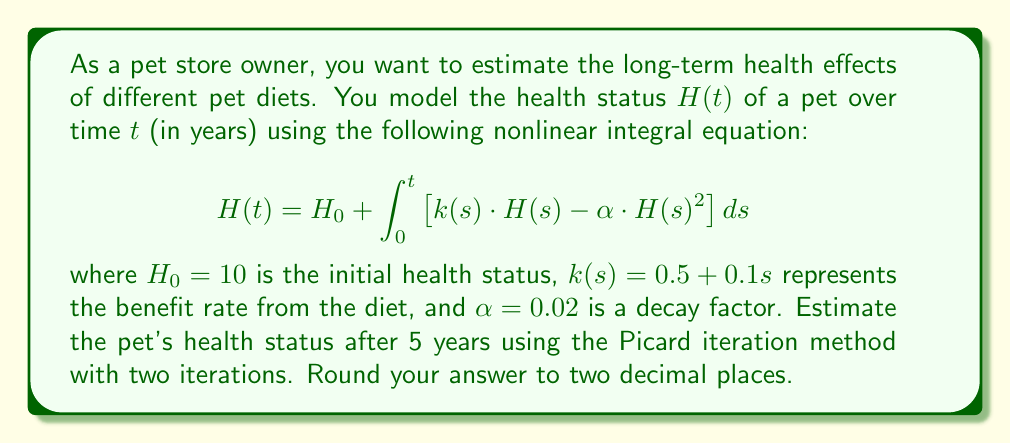Give your solution to this math problem. To solve this problem using the Picard iteration method, we'll follow these steps:

1) Start with the initial approximation $H_0(t) = 10$ (constant function).

2) For the first iteration, substitute $H_0(t)$ into the right-hand side of the equation:

   $$H_1(t) = 10 + \int_0^t \left[(0.5 + 0.1s) \cdot 10 - 0.02 \cdot 10^2\right] ds$$

3) Simplify and evaluate the integral:

   $$H_1(t) = 10 + \int_0^t [5 + s - 2] ds = 10 + \int_0^t [3 + s] ds$$
   $$H_1(t) = 10 + [3t + \frac{1}{2}t^2]_0^t = 10 + 3t + \frac{1}{2}t^2$$

4) For the second iteration, substitute $H_1(t)$ into the right-hand side:

   $$H_2(t) = 10 + \int_0^t \left[(0.5 + 0.1s) \cdot (10 + 3s + \frac{1}{2}s^2) - 0.02 \cdot (10 + 3s + \frac{1}{2}s^2)^2\right] ds$$

5) Expand and simplify the integrand:

   $$H_2(t) = 10 + \int_0^t \left[5 + 1.5s + 0.25s^2 + s + 0.3s^2 + 0.05s^3 - 2 - 1.2s - 0.2s^2 - 0.18s^2 - 0.06s^3 - 0.005s^4\right] ds$$

   $$H_2(t) = 10 + \int_0^t \left[3 + 0.3s + 0.17s^2 - 0.01s^3 - 0.005s^4\right] ds$$

6) Evaluate the integral:

   $$H_2(t) = 10 + \left[3t + 0.15t^2 + \frac{0.17}{3}t^3 - \frac{0.01}{4}t^4 - \frac{0.005}{5}t^5\right]_0^t$$

7) Substitute $t = 5$ and calculate:

   $$H_2(5) = 10 + 15 + 3.75 + \frac{0.17}{3} \cdot 125 - \frac{0.01}{4} \cdot 625 - \frac{0.005}{5} \cdot 3125$$
   
   $$H_2(5) \approx 35.42$$

8) Round to two decimal places: 35.42
Answer: 35.42 